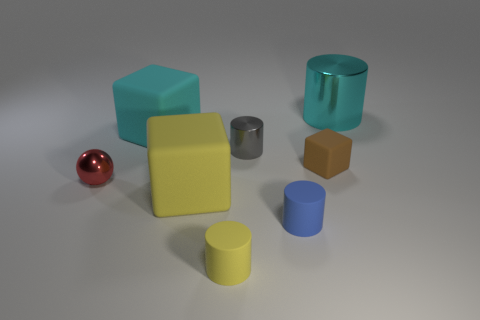Subtract 1 cylinders. How many cylinders are left? 3 Add 1 brown rubber cubes. How many objects exist? 9 Subtract all blocks. How many objects are left? 5 Add 3 cyan rubber blocks. How many cyan rubber blocks are left? 4 Add 4 small brown matte objects. How many small brown matte objects exist? 5 Subtract 0 green spheres. How many objects are left? 8 Subtract all brown metal cubes. Subtract all small blue matte objects. How many objects are left? 7 